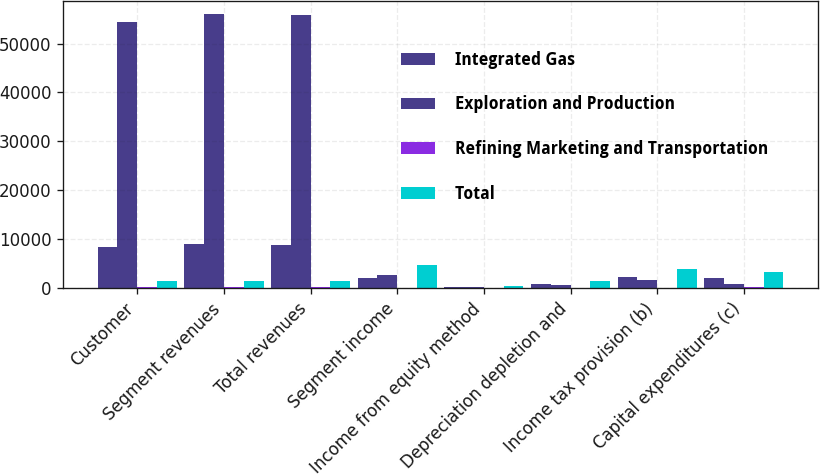Convert chart to OTSL. <chart><loc_0><loc_0><loc_500><loc_500><stacked_bar_chart><ecel><fcel>Customer<fcel>Segment revenues<fcel>Total revenues<fcel>Segment income<fcel>Income from equity method<fcel>Depreciation depletion and<fcel>Income tax provision (b)<fcel>Capital expenditures (c)<nl><fcel>Integrated Gas<fcel>8326<fcel>9010<fcel>8792<fcel>2003<fcel>206<fcel>919<fcel>2371<fcel>2169<nl><fcel>Exploration and Production<fcel>54471<fcel>55941<fcel>55925<fcel>2795<fcel>145<fcel>558<fcel>1642<fcel>916<nl><fcel>Refining Marketing and Transportation<fcel>179<fcel>179<fcel>179<fcel>16<fcel>40<fcel>9<fcel>8<fcel>307<nl><fcel>Total<fcel>1486<fcel>1486<fcel>1486<fcel>4814<fcel>391<fcel>1486<fcel>4021<fcel>3392<nl></chart> 